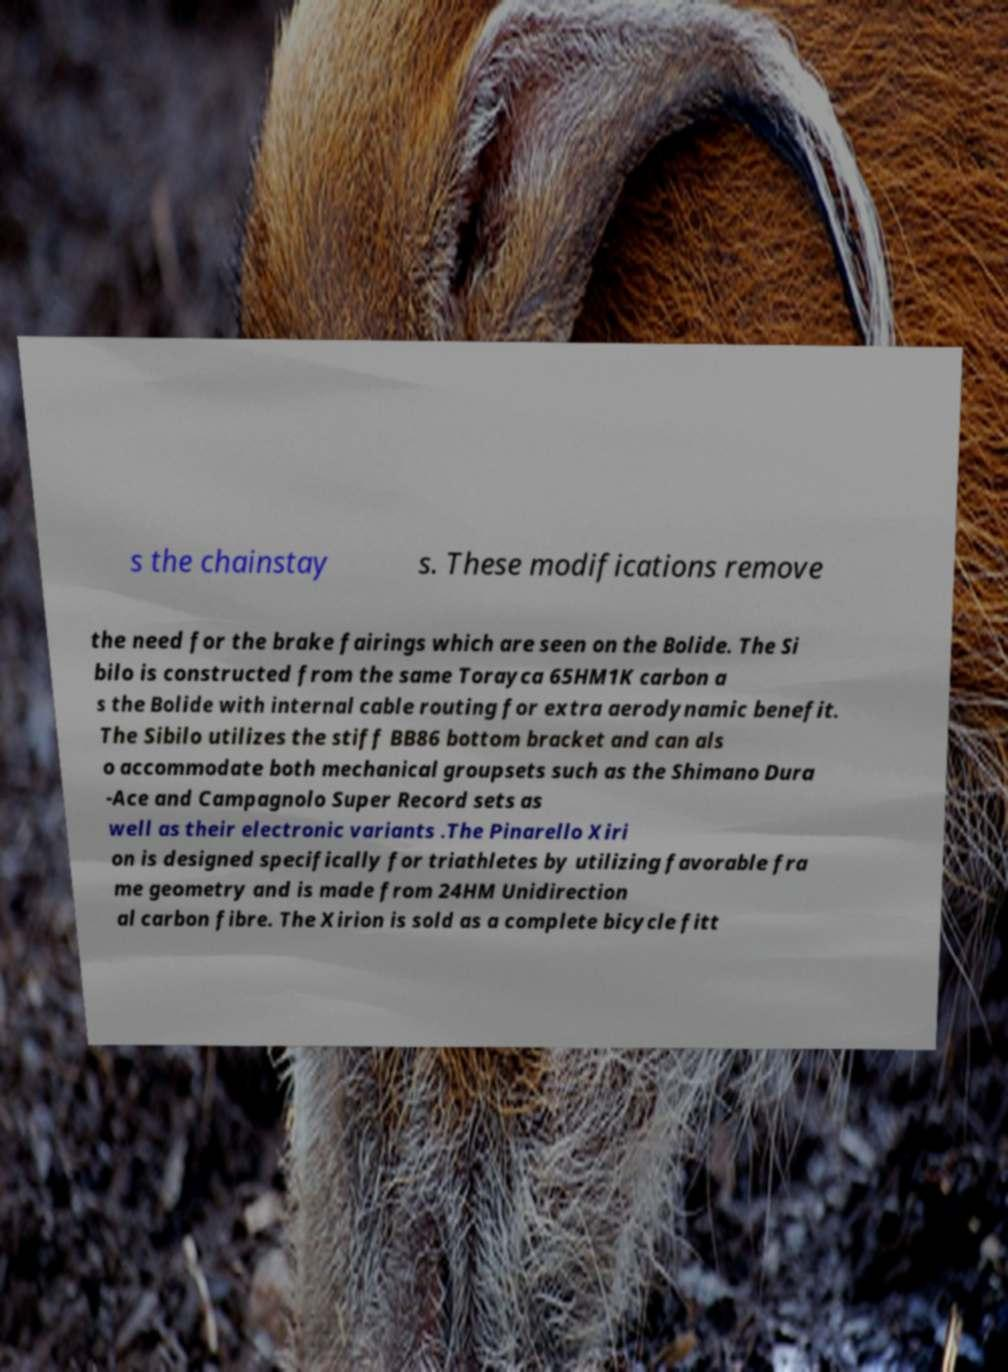Could you extract and type out the text from this image? s the chainstay s. These modifications remove the need for the brake fairings which are seen on the Bolide. The Si bilo is constructed from the same Torayca 65HM1K carbon a s the Bolide with internal cable routing for extra aerodynamic benefit. The Sibilo utilizes the stiff BB86 bottom bracket and can als o accommodate both mechanical groupsets such as the Shimano Dura -Ace and Campagnolo Super Record sets as well as their electronic variants .The Pinarello Xiri on is designed specifically for triathletes by utilizing favorable fra me geometry and is made from 24HM Unidirection al carbon fibre. The Xirion is sold as a complete bicycle fitt 